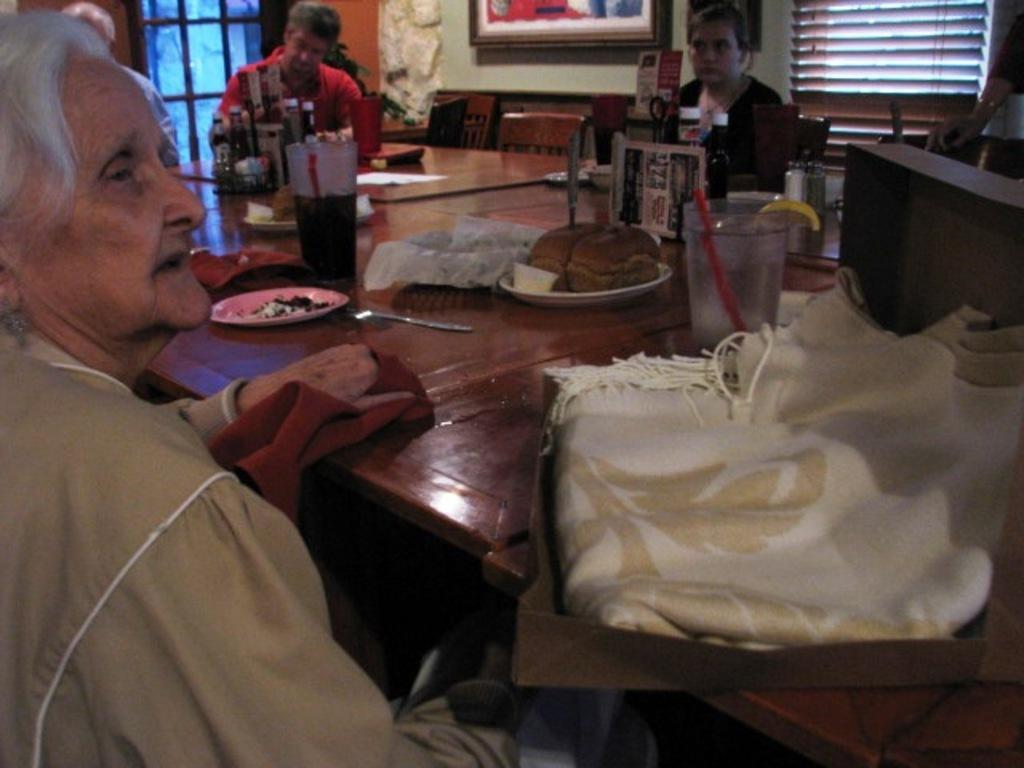Could you give a brief overview of what you see in this image? In the picture we can see a old woman sitting on the chair near to the table and two persons are sitting that side to the table on a chairs, on the table we can find some food items, glass and plates, in the background we can see a wall and window. 